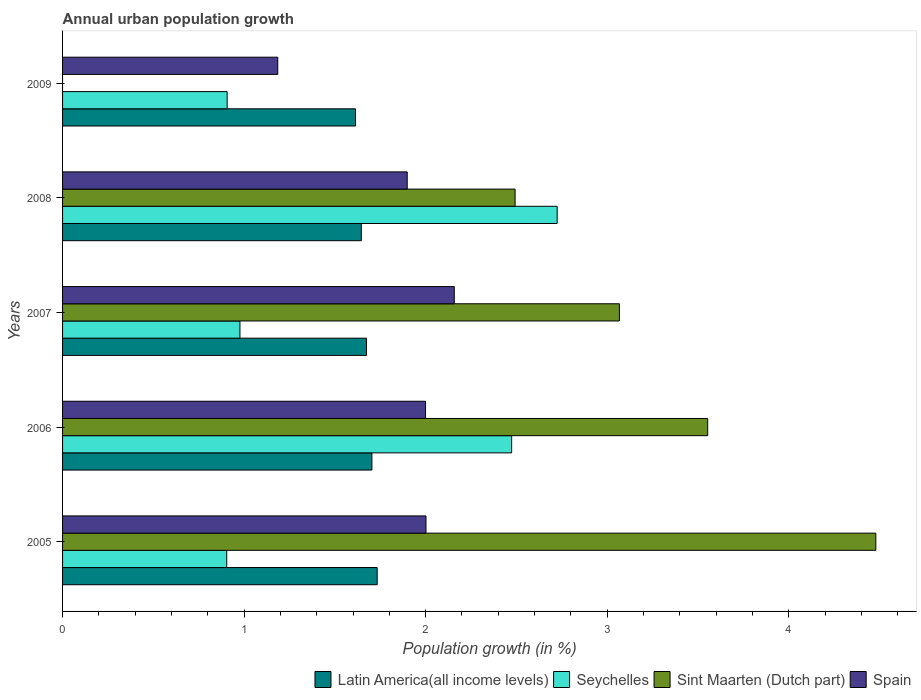How many different coloured bars are there?
Provide a short and direct response. 4. Are the number of bars per tick equal to the number of legend labels?
Give a very brief answer. No. How many bars are there on the 3rd tick from the bottom?
Keep it short and to the point. 4. In how many cases, is the number of bars for a given year not equal to the number of legend labels?
Give a very brief answer. 1. What is the percentage of urban population growth in Spain in 2007?
Give a very brief answer. 2.16. Across all years, what is the maximum percentage of urban population growth in Sint Maarten (Dutch part)?
Your answer should be compact. 4.48. Across all years, what is the minimum percentage of urban population growth in Latin America(all income levels)?
Provide a succinct answer. 1.61. What is the total percentage of urban population growth in Sint Maarten (Dutch part) in the graph?
Your answer should be very brief. 13.59. What is the difference between the percentage of urban population growth in Latin America(all income levels) in 2005 and that in 2009?
Your answer should be compact. 0.12. What is the difference between the percentage of urban population growth in Latin America(all income levels) in 2005 and the percentage of urban population growth in Seychelles in 2007?
Your response must be concise. 0.76. What is the average percentage of urban population growth in Spain per year?
Make the answer very short. 1.85. In the year 2005, what is the difference between the percentage of urban population growth in Sint Maarten (Dutch part) and percentage of urban population growth in Latin America(all income levels)?
Offer a very short reply. 2.75. What is the ratio of the percentage of urban population growth in Latin America(all income levels) in 2005 to that in 2008?
Ensure brevity in your answer.  1.05. What is the difference between the highest and the second highest percentage of urban population growth in Spain?
Provide a succinct answer. 0.16. What is the difference between the highest and the lowest percentage of urban population growth in Latin America(all income levels)?
Provide a succinct answer. 0.12. Is it the case that in every year, the sum of the percentage of urban population growth in Latin America(all income levels) and percentage of urban population growth in Seychelles is greater than the percentage of urban population growth in Spain?
Give a very brief answer. Yes. How many bars are there?
Your answer should be very brief. 19. How many years are there in the graph?
Offer a terse response. 5. What is the difference between two consecutive major ticks on the X-axis?
Ensure brevity in your answer.  1. Where does the legend appear in the graph?
Your response must be concise. Bottom right. How are the legend labels stacked?
Make the answer very short. Horizontal. What is the title of the graph?
Your response must be concise. Annual urban population growth. What is the label or title of the X-axis?
Provide a succinct answer. Population growth (in %). What is the Population growth (in %) in Latin America(all income levels) in 2005?
Keep it short and to the point. 1.73. What is the Population growth (in %) in Seychelles in 2005?
Your answer should be compact. 0.9. What is the Population growth (in %) in Sint Maarten (Dutch part) in 2005?
Your answer should be compact. 4.48. What is the Population growth (in %) of Spain in 2005?
Offer a very short reply. 2. What is the Population growth (in %) in Latin America(all income levels) in 2006?
Offer a very short reply. 1.7. What is the Population growth (in %) in Seychelles in 2006?
Offer a terse response. 2.47. What is the Population growth (in %) in Sint Maarten (Dutch part) in 2006?
Your response must be concise. 3.55. What is the Population growth (in %) in Spain in 2006?
Your answer should be compact. 2. What is the Population growth (in %) in Latin America(all income levels) in 2007?
Your answer should be compact. 1.67. What is the Population growth (in %) in Seychelles in 2007?
Your response must be concise. 0.98. What is the Population growth (in %) in Sint Maarten (Dutch part) in 2007?
Ensure brevity in your answer.  3.07. What is the Population growth (in %) in Spain in 2007?
Keep it short and to the point. 2.16. What is the Population growth (in %) in Latin America(all income levels) in 2008?
Provide a short and direct response. 1.65. What is the Population growth (in %) in Seychelles in 2008?
Keep it short and to the point. 2.72. What is the Population growth (in %) in Sint Maarten (Dutch part) in 2008?
Ensure brevity in your answer.  2.49. What is the Population growth (in %) of Spain in 2008?
Offer a terse response. 1.9. What is the Population growth (in %) in Latin America(all income levels) in 2009?
Keep it short and to the point. 1.61. What is the Population growth (in %) of Seychelles in 2009?
Offer a terse response. 0.91. What is the Population growth (in %) in Spain in 2009?
Offer a very short reply. 1.19. Across all years, what is the maximum Population growth (in %) of Latin America(all income levels)?
Keep it short and to the point. 1.73. Across all years, what is the maximum Population growth (in %) of Seychelles?
Offer a very short reply. 2.72. Across all years, what is the maximum Population growth (in %) in Sint Maarten (Dutch part)?
Provide a succinct answer. 4.48. Across all years, what is the maximum Population growth (in %) in Spain?
Give a very brief answer. 2.16. Across all years, what is the minimum Population growth (in %) in Latin America(all income levels)?
Your response must be concise. 1.61. Across all years, what is the minimum Population growth (in %) in Seychelles?
Give a very brief answer. 0.9. Across all years, what is the minimum Population growth (in %) of Spain?
Provide a short and direct response. 1.19. What is the total Population growth (in %) of Latin America(all income levels) in the graph?
Offer a terse response. 8.37. What is the total Population growth (in %) of Seychelles in the graph?
Your response must be concise. 7.99. What is the total Population growth (in %) in Sint Maarten (Dutch part) in the graph?
Keep it short and to the point. 13.59. What is the total Population growth (in %) of Spain in the graph?
Your answer should be very brief. 9.24. What is the difference between the Population growth (in %) in Latin America(all income levels) in 2005 and that in 2006?
Offer a very short reply. 0.03. What is the difference between the Population growth (in %) in Seychelles in 2005 and that in 2006?
Give a very brief answer. -1.57. What is the difference between the Population growth (in %) in Sint Maarten (Dutch part) in 2005 and that in 2006?
Your answer should be very brief. 0.93. What is the difference between the Population growth (in %) in Spain in 2005 and that in 2006?
Keep it short and to the point. 0. What is the difference between the Population growth (in %) in Latin America(all income levels) in 2005 and that in 2007?
Offer a very short reply. 0.06. What is the difference between the Population growth (in %) in Seychelles in 2005 and that in 2007?
Your response must be concise. -0.07. What is the difference between the Population growth (in %) in Sint Maarten (Dutch part) in 2005 and that in 2007?
Your answer should be compact. 1.41. What is the difference between the Population growth (in %) in Spain in 2005 and that in 2007?
Keep it short and to the point. -0.16. What is the difference between the Population growth (in %) in Latin America(all income levels) in 2005 and that in 2008?
Make the answer very short. 0.09. What is the difference between the Population growth (in %) in Seychelles in 2005 and that in 2008?
Keep it short and to the point. -1.82. What is the difference between the Population growth (in %) in Sint Maarten (Dutch part) in 2005 and that in 2008?
Your response must be concise. 1.99. What is the difference between the Population growth (in %) of Spain in 2005 and that in 2008?
Your answer should be very brief. 0.1. What is the difference between the Population growth (in %) in Latin America(all income levels) in 2005 and that in 2009?
Give a very brief answer. 0.12. What is the difference between the Population growth (in %) in Seychelles in 2005 and that in 2009?
Provide a short and direct response. -0. What is the difference between the Population growth (in %) in Spain in 2005 and that in 2009?
Make the answer very short. 0.82. What is the difference between the Population growth (in %) of Latin America(all income levels) in 2006 and that in 2007?
Ensure brevity in your answer.  0.03. What is the difference between the Population growth (in %) in Seychelles in 2006 and that in 2007?
Offer a terse response. 1.5. What is the difference between the Population growth (in %) in Sint Maarten (Dutch part) in 2006 and that in 2007?
Provide a succinct answer. 0.49. What is the difference between the Population growth (in %) of Spain in 2006 and that in 2007?
Offer a very short reply. -0.16. What is the difference between the Population growth (in %) of Latin America(all income levels) in 2006 and that in 2008?
Provide a succinct answer. 0.06. What is the difference between the Population growth (in %) of Seychelles in 2006 and that in 2008?
Your response must be concise. -0.25. What is the difference between the Population growth (in %) of Sint Maarten (Dutch part) in 2006 and that in 2008?
Offer a terse response. 1.06. What is the difference between the Population growth (in %) of Spain in 2006 and that in 2008?
Your answer should be compact. 0.1. What is the difference between the Population growth (in %) of Latin America(all income levels) in 2006 and that in 2009?
Your answer should be very brief. 0.09. What is the difference between the Population growth (in %) of Seychelles in 2006 and that in 2009?
Give a very brief answer. 1.57. What is the difference between the Population growth (in %) in Spain in 2006 and that in 2009?
Your answer should be very brief. 0.81. What is the difference between the Population growth (in %) in Latin America(all income levels) in 2007 and that in 2008?
Your response must be concise. 0.03. What is the difference between the Population growth (in %) of Seychelles in 2007 and that in 2008?
Make the answer very short. -1.75. What is the difference between the Population growth (in %) in Sint Maarten (Dutch part) in 2007 and that in 2008?
Ensure brevity in your answer.  0.57. What is the difference between the Population growth (in %) in Spain in 2007 and that in 2008?
Ensure brevity in your answer.  0.26. What is the difference between the Population growth (in %) of Latin America(all income levels) in 2007 and that in 2009?
Ensure brevity in your answer.  0.06. What is the difference between the Population growth (in %) of Seychelles in 2007 and that in 2009?
Your answer should be compact. 0.07. What is the difference between the Population growth (in %) in Spain in 2007 and that in 2009?
Ensure brevity in your answer.  0.97. What is the difference between the Population growth (in %) of Latin America(all income levels) in 2008 and that in 2009?
Your answer should be compact. 0.03. What is the difference between the Population growth (in %) in Seychelles in 2008 and that in 2009?
Your answer should be very brief. 1.82. What is the difference between the Population growth (in %) of Spain in 2008 and that in 2009?
Your answer should be very brief. 0.71. What is the difference between the Population growth (in %) in Latin America(all income levels) in 2005 and the Population growth (in %) in Seychelles in 2006?
Ensure brevity in your answer.  -0.74. What is the difference between the Population growth (in %) of Latin America(all income levels) in 2005 and the Population growth (in %) of Sint Maarten (Dutch part) in 2006?
Ensure brevity in your answer.  -1.82. What is the difference between the Population growth (in %) in Latin America(all income levels) in 2005 and the Population growth (in %) in Spain in 2006?
Provide a succinct answer. -0.27. What is the difference between the Population growth (in %) in Seychelles in 2005 and the Population growth (in %) in Sint Maarten (Dutch part) in 2006?
Provide a short and direct response. -2.65. What is the difference between the Population growth (in %) in Seychelles in 2005 and the Population growth (in %) in Spain in 2006?
Your answer should be compact. -1.09. What is the difference between the Population growth (in %) in Sint Maarten (Dutch part) in 2005 and the Population growth (in %) in Spain in 2006?
Keep it short and to the point. 2.48. What is the difference between the Population growth (in %) of Latin America(all income levels) in 2005 and the Population growth (in %) of Seychelles in 2007?
Your answer should be compact. 0.76. What is the difference between the Population growth (in %) of Latin America(all income levels) in 2005 and the Population growth (in %) of Sint Maarten (Dutch part) in 2007?
Ensure brevity in your answer.  -1.33. What is the difference between the Population growth (in %) of Latin America(all income levels) in 2005 and the Population growth (in %) of Spain in 2007?
Your response must be concise. -0.42. What is the difference between the Population growth (in %) of Seychelles in 2005 and the Population growth (in %) of Sint Maarten (Dutch part) in 2007?
Provide a short and direct response. -2.16. What is the difference between the Population growth (in %) of Seychelles in 2005 and the Population growth (in %) of Spain in 2007?
Your answer should be very brief. -1.25. What is the difference between the Population growth (in %) in Sint Maarten (Dutch part) in 2005 and the Population growth (in %) in Spain in 2007?
Keep it short and to the point. 2.32. What is the difference between the Population growth (in %) in Latin America(all income levels) in 2005 and the Population growth (in %) in Seychelles in 2008?
Offer a very short reply. -0.99. What is the difference between the Population growth (in %) of Latin America(all income levels) in 2005 and the Population growth (in %) of Sint Maarten (Dutch part) in 2008?
Your answer should be compact. -0.76. What is the difference between the Population growth (in %) of Latin America(all income levels) in 2005 and the Population growth (in %) of Spain in 2008?
Your answer should be compact. -0.17. What is the difference between the Population growth (in %) in Seychelles in 2005 and the Population growth (in %) in Sint Maarten (Dutch part) in 2008?
Offer a terse response. -1.59. What is the difference between the Population growth (in %) in Seychelles in 2005 and the Population growth (in %) in Spain in 2008?
Ensure brevity in your answer.  -0.99. What is the difference between the Population growth (in %) in Sint Maarten (Dutch part) in 2005 and the Population growth (in %) in Spain in 2008?
Ensure brevity in your answer.  2.58. What is the difference between the Population growth (in %) in Latin America(all income levels) in 2005 and the Population growth (in %) in Seychelles in 2009?
Keep it short and to the point. 0.83. What is the difference between the Population growth (in %) of Latin America(all income levels) in 2005 and the Population growth (in %) of Spain in 2009?
Provide a succinct answer. 0.55. What is the difference between the Population growth (in %) in Seychelles in 2005 and the Population growth (in %) in Spain in 2009?
Your answer should be compact. -0.28. What is the difference between the Population growth (in %) in Sint Maarten (Dutch part) in 2005 and the Population growth (in %) in Spain in 2009?
Your answer should be very brief. 3.29. What is the difference between the Population growth (in %) in Latin America(all income levels) in 2006 and the Population growth (in %) in Seychelles in 2007?
Provide a short and direct response. 0.73. What is the difference between the Population growth (in %) of Latin America(all income levels) in 2006 and the Population growth (in %) of Sint Maarten (Dutch part) in 2007?
Make the answer very short. -1.36. What is the difference between the Population growth (in %) in Latin America(all income levels) in 2006 and the Population growth (in %) in Spain in 2007?
Keep it short and to the point. -0.45. What is the difference between the Population growth (in %) in Seychelles in 2006 and the Population growth (in %) in Sint Maarten (Dutch part) in 2007?
Make the answer very short. -0.59. What is the difference between the Population growth (in %) of Seychelles in 2006 and the Population growth (in %) of Spain in 2007?
Make the answer very short. 0.32. What is the difference between the Population growth (in %) in Sint Maarten (Dutch part) in 2006 and the Population growth (in %) in Spain in 2007?
Ensure brevity in your answer.  1.4. What is the difference between the Population growth (in %) of Latin America(all income levels) in 2006 and the Population growth (in %) of Seychelles in 2008?
Offer a terse response. -1.02. What is the difference between the Population growth (in %) in Latin America(all income levels) in 2006 and the Population growth (in %) in Sint Maarten (Dutch part) in 2008?
Your answer should be compact. -0.79. What is the difference between the Population growth (in %) of Latin America(all income levels) in 2006 and the Population growth (in %) of Spain in 2008?
Give a very brief answer. -0.19. What is the difference between the Population growth (in %) in Seychelles in 2006 and the Population growth (in %) in Sint Maarten (Dutch part) in 2008?
Offer a terse response. -0.02. What is the difference between the Population growth (in %) of Seychelles in 2006 and the Population growth (in %) of Spain in 2008?
Provide a succinct answer. 0.58. What is the difference between the Population growth (in %) in Sint Maarten (Dutch part) in 2006 and the Population growth (in %) in Spain in 2008?
Offer a terse response. 1.65. What is the difference between the Population growth (in %) of Latin America(all income levels) in 2006 and the Population growth (in %) of Seychelles in 2009?
Provide a short and direct response. 0.8. What is the difference between the Population growth (in %) in Latin America(all income levels) in 2006 and the Population growth (in %) in Spain in 2009?
Ensure brevity in your answer.  0.52. What is the difference between the Population growth (in %) in Seychelles in 2006 and the Population growth (in %) in Spain in 2009?
Give a very brief answer. 1.29. What is the difference between the Population growth (in %) of Sint Maarten (Dutch part) in 2006 and the Population growth (in %) of Spain in 2009?
Ensure brevity in your answer.  2.37. What is the difference between the Population growth (in %) of Latin America(all income levels) in 2007 and the Population growth (in %) of Seychelles in 2008?
Give a very brief answer. -1.05. What is the difference between the Population growth (in %) of Latin America(all income levels) in 2007 and the Population growth (in %) of Sint Maarten (Dutch part) in 2008?
Provide a succinct answer. -0.82. What is the difference between the Population growth (in %) in Latin America(all income levels) in 2007 and the Population growth (in %) in Spain in 2008?
Your answer should be compact. -0.22. What is the difference between the Population growth (in %) in Seychelles in 2007 and the Population growth (in %) in Sint Maarten (Dutch part) in 2008?
Keep it short and to the point. -1.52. What is the difference between the Population growth (in %) in Seychelles in 2007 and the Population growth (in %) in Spain in 2008?
Ensure brevity in your answer.  -0.92. What is the difference between the Population growth (in %) of Sint Maarten (Dutch part) in 2007 and the Population growth (in %) of Spain in 2008?
Offer a very short reply. 1.17. What is the difference between the Population growth (in %) in Latin America(all income levels) in 2007 and the Population growth (in %) in Seychelles in 2009?
Offer a very short reply. 0.77. What is the difference between the Population growth (in %) of Latin America(all income levels) in 2007 and the Population growth (in %) of Spain in 2009?
Make the answer very short. 0.49. What is the difference between the Population growth (in %) in Seychelles in 2007 and the Population growth (in %) in Spain in 2009?
Give a very brief answer. -0.21. What is the difference between the Population growth (in %) of Sint Maarten (Dutch part) in 2007 and the Population growth (in %) of Spain in 2009?
Give a very brief answer. 1.88. What is the difference between the Population growth (in %) of Latin America(all income levels) in 2008 and the Population growth (in %) of Seychelles in 2009?
Make the answer very short. 0.74. What is the difference between the Population growth (in %) in Latin America(all income levels) in 2008 and the Population growth (in %) in Spain in 2009?
Provide a short and direct response. 0.46. What is the difference between the Population growth (in %) of Seychelles in 2008 and the Population growth (in %) of Spain in 2009?
Provide a succinct answer. 1.54. What is the difference between the Population growth (in %) of Sint Maarten (Dutch part) in 2008 and the Population growth (in %) of Spain in 2009?
Your response must be concise. 1.31. What is the average Population growth (in %) in Latin America(all income levels) per year?
Provide a short and direct response. 1.67. What is the average Population growth (in %) of Seychelles per year?
Give a very brief answer. 1.6. What is the average Population growth (in %) in Sint Maarten (Dutch part) per year?
Provide a short and direct response. 2.72. What is the average Population growth (in %) in Spain per year?
Offer a terse response. 1.85. In the year 2005, what is the difference between the Population growth (in %) of Latin America(all income levels) and Population growth (in %) of Seychelles?
Give a very brief answer. 0.83. In the year 2005, what is the difference between the Population growth (in %) of Latin America(all income levels) and Population growth (in %) of Sint Maarten (Dutch part)?
Provide a short and direct response. -2.75. In the year 2005, what is the difference between the Population growth (in %) of Latin America(all income levels) and Population growth (in %) of Spain?
Provide a short and direct response. -0.27. In the year 2005, what is the difference between the Population growth (in %) in Seychelles and Population growth (in %) in Sint Maarten (Dutch part)?
Your response must be concise. -3.58. In the year 2005, what is the difference between the Population growth (in %) in Seychelles and Population growth (in %) in Spain?
Provide a short and direct response. -1.1. In the year 2005, what is the difference between the Population growth (in %) of Sint Maarten (Dutch part) and Population growth (in %) of Spain?
Provide a short and direct response. 2.48. In the year 2006, what is the difference between the Population growth (in %) of Latin America(all income levels) and Population growth (in %) of Seychelles?
Provide a short and direct response. -0.77. In the year 2006, what is the difference between the Population growth (in %) in Latin America(all income levels) and Population growth (in %) in Sint Maarten (Dutch part)?
Provide a succinct answer. -1.85. In the year 2006, what is the difference between the Population growth (in %) in Latin America(all income levels) and Population growth (in %) in Spain?
Give a very brief answer. -0.3. In the year 2006, what is the difference between the Population growth (in %) of Seychelles and Population growth (in %) of Sint Maarten (Dutch part)?
Your response must be concise. -1.08. In the year 2006, what is the difference between the Population growth (in %) of Seychelles and Population growth (in %) of Spain?
Provide a short and direct response. 0.47. In the year 2006, what is the difference between the Population growth (in %) of Sint Maarten (Dutch part) and Population growth (in %) of Spain?
Make the answer very short. 1.55. In the year 2007, what is the difference between the Population growth (in %) of Latin America(all income levels) and Population growth (in %) of Seychelles?
Your answer should be very brief. 0.7. In the year 2007, what is the difference between the Population growth (in %) in Latin America(all income levels) and Population growth (in %) in Sint Maarten (Dutch part)?
Make the answer very short. -1.39. In the year 2007, what is the difference between the Population growth (in %) of Latin America(all income levels) and Population growth (in %) of Spain?
Offer a terse response. -0.48. In the year 2007, what is the difference between the Population growth (in %) in Seychelles and Population growth (in %) in Sint Maarten (Dutch part)?
Your answer should be compact. -2.09. In the year 2007, what is the difference between the Population growth (in %) of Seychelles and Population growth (in %) of Spain?
Offer a terse response. -1.18. In the year 2007, what is the difference between the Population growth (in %) of Sint Maarten (Dutch part) and Population growth (in %) of Spain?
Offer a very short reply. 0.91. In the year 2008, what is the difference between the Population growth (in %) of Latin America(all income levels) and Population growth (in %) of Seychelles?
Your answer should be compact. -1.08. In the year 2008, what is the difference between the Population growth (in %) of Latin America(all income levels) and Population growth (in %) of Sint Maarten (Dutch part)?
Keep it short and to the point. -0.85. In the year 2008, what is the difference between the Population growth (in %) in Latin America(all income levels) and Population growth (in %) in Spain?
Offer a very short reply. -0.25. In the year 2008, what is the difference between the Population growth (in %) in Seychelles and Population growth (in %) in Sint Maarten (Dutch part)?
Your response must be concise. 0.23. In the year 2008, what is the difference between the Population growth (in %) of Seychelles and Population growth (in %) of Spain?
Make the answer very short. 0.83. In the year 2008, what is the difference between the Population growth (in %) in Sint Maarten (Dutch part) and Population growth (in %) in Spain?
Ensure brevity in your answer.  0.59. In the year 2009, what is the difference between the Population growth (in %) of Latin America(all income levels) and Population growth (in %) of Seychelles?
Your answer should be compact. 0.71. In the year 2009, what is the difference between the Population growth (in %) in Latin America(all income levels) and Population growth (in %) in Spain?
Provide a short and direct response. 0.43. In the year 2009, what is the difference between the Population growth (in %) in Seychelles and Population growth (in %) in Spain?
Give a very brief answer. -0.28. What is the ratio of the Population growth (in %) in Latin America(all income levels) in 2005 to that in 2006?
Keep it short and to the point. 1.02. What is the ratio of the Population growth (in %) of Seychelles in 2005 to that in 2006?
Ensure brevity in your answer.  0.37. What is the ratio of the Population growth (in %) of Sint Maarten (Dutch part) in 2005 to that in 2006?
Provide a succinct answer. 1.26. What is the ratio of the Population growth (in %) in Spain in 2005 to that in 2006?
Your answer should be very brief. 1. What is the ratio of the Population growth (in %) of Latin America(all income levels) in 2005 to that in 2007?
Your response must be concise. 1.04. What is the ratio of the Population growth (in %) in Seychelles in 2005 to that in 2007?
Keep it short and to the point. 0.93. What is the ratio of the Population growth (in %) in Sint Maarten (Dutch part) in 2005 to that in 2007?
Offer a very short reply. 1.46. What is the ratio of the Population growth (in %) in Spain in 2005 to that in 2007?
Offer a terse response. 0.93. What is the ratio of the Population growth (in %) of Latin America(all income levels) in 2005 to that in 2008?
Your answer should be very brief. 1.05. What is the ratio of the Population growth (in %) in Seychelles in 2005 to that in 2008?
Offer a very short reply. 0.33. What is the ratio of the Population growth (in %) in Sint Maarten (Dutch part) in 2005 to that in 2008?
Your answer should be compact. 1.8. What is the ratio of the Population growth (in %) of Spain in 2005 to that in 2008?
Offer a very short reply. 1.05. What is the ratio of the Population growth (in %) in Latin America(all income levels) in 2005 to that in 2009?
Ensure brevity in your answer.  1.07. What is the ratio of the Population growth (in %) in Seychelles in 2005 to that in 2009?
Provide a short and direct response. 1. What is the ratio of the Population growth (in %) in Spain in 2005 to that in 2009?
Your answer should be very brief. 1.69. What is the ratio of the Population growth (in %) in Latin America(all income levels) in 2006 to that in 2007?
Your response must be concise. 1.02. What is the ratio of the Population growth (in %) of Seychelles in 2006 to that in 2007?
Keep it short and to the point. 2.53. What is the ratio of the Population growth (in %) of Sint Maarten (Dutch part) in 2006 to that in 2007?
Your answer should be very brief. 1.16. What is the ratio of the Population growth (in %) of Spain in 2006 to that in 2007?
Provide a succinct answer. 0.93. What is the ratio of the Population growth (in %) in Latin America(all income levels) in 2006 to that in 2008?
Make the answer very short. 1.04. What is the ratio of the Population growth (in %) in Seychelles in 2006 to that in 2008?
Provide a short and direct response. 0.91. What is the ratio of the Population growth (in %) of Sint Maarten (Dutch part) in 2006 to that in 2008?
Make the answer very short. 1.43. What is the ratio of the Population growth (in %) of Spain in 2006 to that in 2008?
Your response must be concise. 1.05. What is the ratio of the Population growth (in %) of Latin America(all income levels) in 2006 to that in 2009?
Offer a terse response. 1.06. What is the ratio of the Population growth (in %) of Seychelles in 2006 to that in 2009?
Make the answer very short. 2.73. What is the ratio of the Population growth (in %) in Spain in 2006 to that in 2009?
Provide a succinct answer. 1.69. What is the ratio of the Population growth (in %) of Latin America(all income levels) in 2007 to that in 2008?
Provide a short and direct response. 1.02. What is the ratio of the Population growth (in %) of Seychelles in 2007 to that in 2008?
Your answer should be very brief. 0.36. What is the ratio of the Population growth (in %) of Sint Maarten (Dutch part) in 2007 to that in 2008?
Your response must be concise. 1.23. What is the ratio of the Population growth (in %) in Spain in 2007 to that in 2008?
Make the answer very short. 1.14. What is the ratio of the Population growth (in %) in Latin America(all income levels) in 2007 to that in 2009?
Your answer should be compact. 1.04. What is the ratio of the Population growth (in %) in Seychelles in 2007 to that in 2009?
Provide a short and direct response. 1.08. What is the ratio of the Population growth (in %) in Spain in 2007 to that in 2009?
Your answer should be very brief. 1.82. What is the ratio of the Population growth (in %) of Latin America(all income levels) in 2008 to that in 2009?
Your answer should be compact. 1.02. What is the ratio of the Population growth (in %) of Seychelles in 2008 to that in 2009?
Your answer should be compact. 3.01. What is the ratio of the Population growth (in %) of Spain in 2008 to that in 2009?
Give a very brief answer. 1.6. What is the difference between the highest and the second highest Population growth (in %) in Latin America(all income levels)?
Ensure brevity in your answer.  0.03. What is the difference between the highest and the second highest Population growth (in %) in Seychelles?
Offer a terse response. 0.25. What is the difference between the highest and the second highest Population growth (in %) of Sint Maarten (Dutch part)?
Your answer should be compact. 0.93. What is the difference between the highest and the second highest Population growth (in %) of Spain?
Offer a very short reply. 0.16. What is the difference between the highest and the lowest Population growth (in %) of Latin America(all income levels)?
Give a very brief answer. 0.12. What is the difference between the highest and the lowest Population growth (in %) of Seychelles?
Ensure brevity in your answer.  1.82. What is the difference between the highest and the lowest Population growth (in %) in Sint Maarten (Dutch part)?
Give a very brief answer. 4.48. What is the difference between the highest and the lowest Population growth (in %) in Spain?
Offer a very short reply. 0.97. 